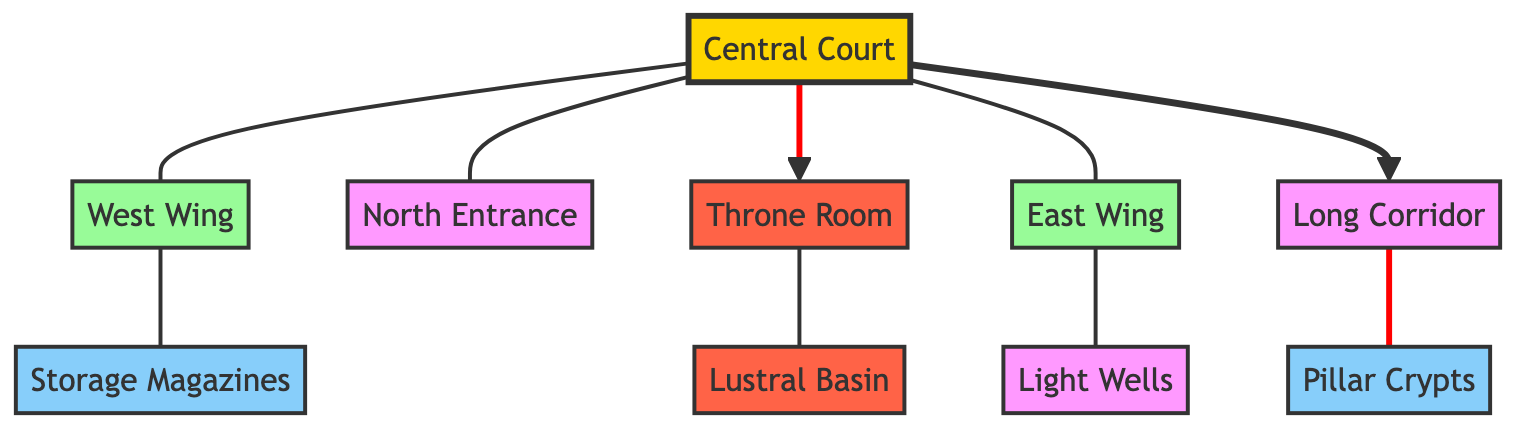What is the central feature of the palace layout? The central feature of the palace layout is the Central Court, which acts as a gathering and ceremonial space connecting various wings and rooms.
Answer: Central Court How many wings are present in the diagram? The diagram includes two wings: the West Wing and the East Wing. These are branched off from the Central Court, highlighting their importance in the palace structure.
Answer: 2 What connects the Central Court to the Throne Room? The connection between the Central Court and the Throne Room is indicated with a direct arrow, signifying a significant relationship and flow of movement towards the ceremonial area.
Answer: Throne Room Which area is linked directly to storage facilities? The West Wing is directly linked to the Storage Magazines, showing that this wing plays a vital role in the storage aspect of the palace.
Answer: Storage Magazines What purpose does the Lustral Basin serve in relation to the Throne Room? The Lustral Basin is adjacent to the Throne Room, suggesting its function is associated with ritualistic or ceremonial purposes, perhaps for purification.
Answer: Ritual What is located in the North Entrance? The North Entrance serves as an access point to the Central Court, indicating its role as a primary entrance into the palace layout.
Answer: North Entrance Describe the function of the Light Wells in this palace structure. The Light Wells are connected to the East Wing, indicating their role in illuminating the space, contributing to the overall architectural design of the palace.
Answer: Illumination How many storage areas are identified in the diagram? The diagram identifies two storage areas: the Storage Magazines and the Pillar Crypts, both crucial for storage within the palace layout.
Answer: 2 What feature connects the Long Corridor to the Pillar Crypts? The Long Corridor connects directly to the Pillar Crypts, emphasizing the flow of movement and accessibility within the storage area of the palace.
Answer: Long Corridor 